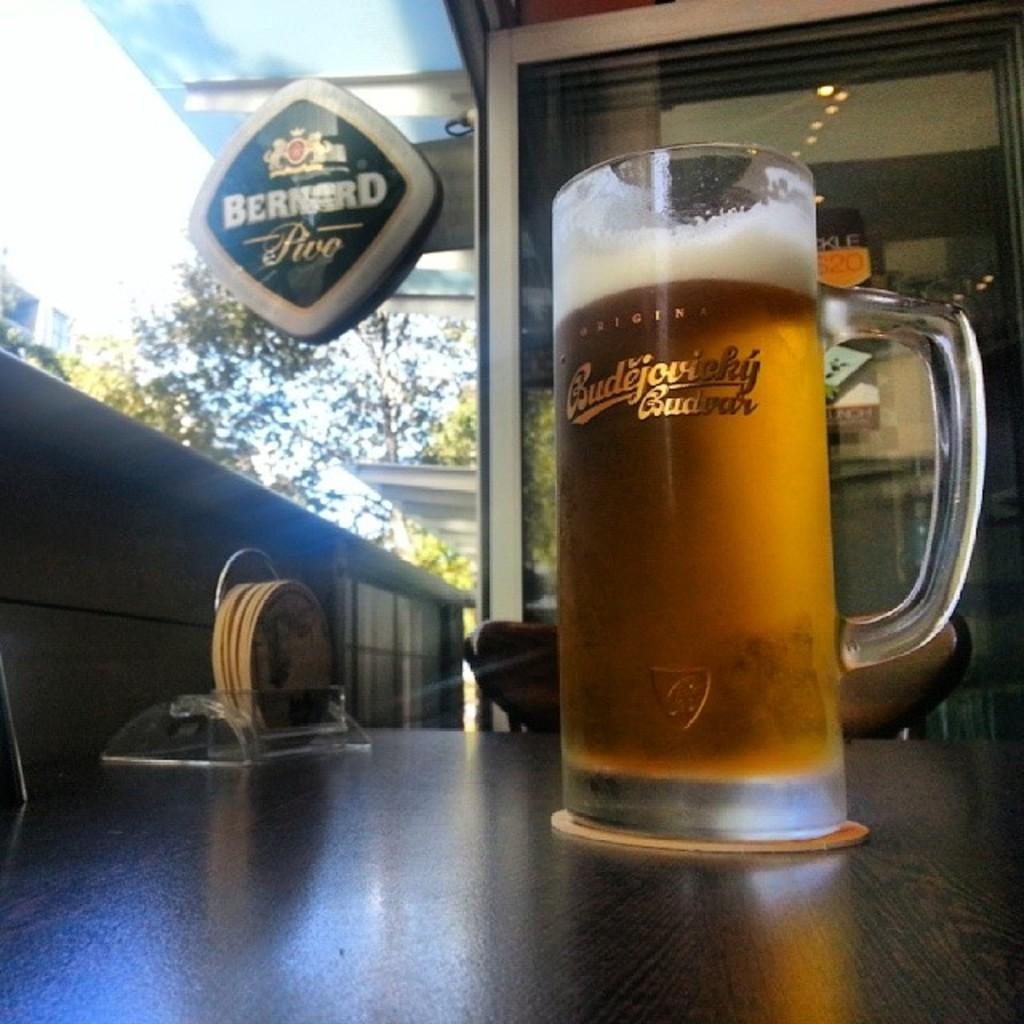<image>
Give a short and clear explanation of the subsequent image. a mug of beer with the name Budejovicky 